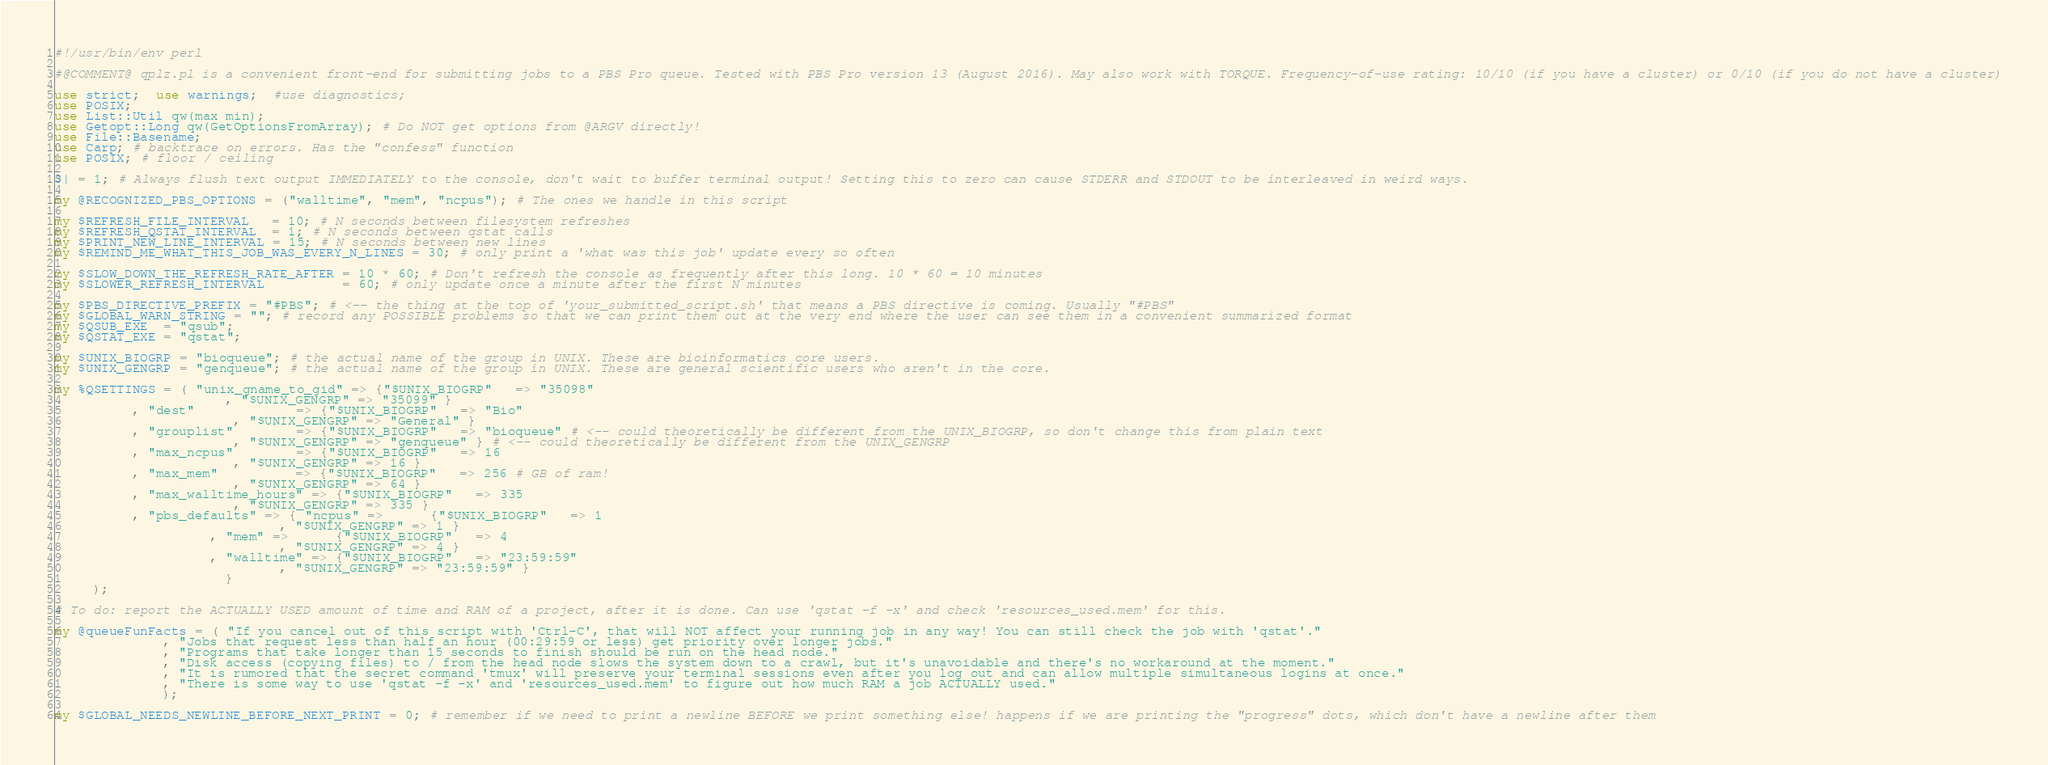Convert code to text. <code><loc_0><loc_0><loc_500><loc_500><_Perl_>#!/usr/bin/env perl

#@COMMENT@ qplz.pl is a convenient front-end for submitting jobs to a PBS Pro queue. Tested with PBS Pro version 13 (August 2016). May also work with TORQUE. Frequency-of-use rating: 10/10 (if you have a cluster) or 0/10 (if you do not have a cluster)

use strict;  use warnings;  #use diagnostics;
use POSIX;
use List::Util qw(max min);
use Getopt::Long qw(GetOptionsFromArray); # Do NOT get options from @ARGV directly!
use File::Basename;
use Carp; # backtrace on errors. Has the "confess" function
use POSIX; # floor / ceiling

$| = 1; # Always flush text output IMMEDIATELY to the console, don't wait to buffer terminal output! Setting this to zero can cause STDERR and STDOUT to be interleaved in weird ways.

my @RECOGNIZED_PBS_OPTIONS = ("walltime", "mem", "ncpus"); # The ones we handle in this script

my $REFRESH_FILE_INTERVAL   = 10; # N seconds between filesystem refreshes
my $REFRESH_QSTAT_INTERVAL  = 1; # N seconds between qstat calls
my $PRINT_NEW_LINE_INTERVAL = 15; # N seconds between new lines
my $REMIND_ME_WHAT_THIS_JOB_WAS_EVERY_N_LINES = 30; # only print a 'what was this job' update every so often

my $SLOW_DOWN_THE_REFRESH_RATE_AFTER = 10 * 60; # Don't refresh the console as frequently after this long. 10 * 60 = 10 minutes
my $SLOWER_REFRESH_INTERVAL          = 60; # only update once a minute after the first N minutes

my $PBS_DIRECTIVE_PREFIX = "#PBS"; # <-- the thing at the top of 'your_submitted_script.sh' that means a PBS directive is coming. Usually "#PBS"
my $GLOBAL_WARN_STRING = ""; # record any POSSIBLE problems so that we can print them out at the very end where the user can see them in a convenient summarized format
my $QSUB_EXE  = "qsub";
my $QSTAT_EXE = "qstat";

my $UNIX_BIOGRP = "bioqueue"; # the actual name of the group in UNIX. These are bioinformatics core users.
my $UNIX_GENGRP = "genqueue"; # the actual name of the group in UNIX. These are general scientific users who aren't in the core.

my %QSETTINGS = ( "unix_gname_to_gid" => {"$UNIX_BIOGRP"   => "35098"
					  , "$UNIX_GENGRP" => "35099" }
		  , "dest"             => {"$UNIX_BIOGRP"   => "Bio"
					   , "$UNIX_GENGRP" => "General" }
		  , "grouplist"        => {"$UNIX_BIOGRP"   => "bioqueue" # <-- could theoretically be different from the UNIX_BIOGRP, so don't change this from plain text
					   , "$UNIX_GENGRP" => "genqueue" } # <-- could theoretically be different from the UNIX_GENGRP
		  , "max_ncpus"        => {"$UNIX_BIOGRP"   => 16
					   , "$UNIX_GENGRP" => 16 }
		  , "max_mem"          => {"$UNIX_BIOGRP"   => 256 # GB of ram!
					   , "$UNIX_GENGRP" => 64 }
		  , "max_walltime_hours" => {"$UNIX_BIOGRP"   => 335
					   , "$UNIX_GENGRP" => 335 }
		  , "pbs_defaults" => { "ncpus" =>      {"$UNIX_BIOGRP"   => 1
							 , "$UNIX_GENGRP" => 1 }
					, "mem" =>      {"$UNIX_BIOGRP"   => 4
							 , "$UNIX_GENGRP" => 4 }
					, "walltime" => {"$UNIX_BIOGRP"   => "23:59:59"
							 , "$UNIX_GENGRP" => "23:59:59" }
				      }
	 );

# To do: report the ACTUALLY USED amount of time and RAM of a project, after it is done. Can use 'qstat -f -x' and check 'resources_used.mem' for this.

my @queueFunFacts = ( "If you cancel out of this script with 'Ctrl-C', that will NOT affect your running job in any way! You can still check the job with 'qstat'."
		      , "Jobs that request less than half an hour (00:29:59 or less) get priority over longer jobs."
		      , "Programs that take longer than 15 seconds to finish should be run on the head node."
		      , "Disk access (copying files) to / from the head node slows the system down to a crawl, but it's unavoidable and there's no workaround at the moment."
		      , "It is rumored that the secret command 'tmux' will preserve your terminal sessions even after you log out and can allow multiple simultaneous logins at once."
		      , "There is some way to use 'qstat -f -x' and 'resources_used.mem' to figure out how much RAM a job ACTUALLY used."
		      );

my $GLOBAL_NEEDS_NEWLINE_BEFORE_NEXT_PRINT = 0; # remember if we need to print a newline BEFORE we print something else! happens if we are printing the "progress" dots, which don't have a newline after them
</code> 